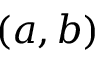Convert formula to latex. <formula><loc_0><loc_0><loc_500><loc_500>( a , b )</formula> 